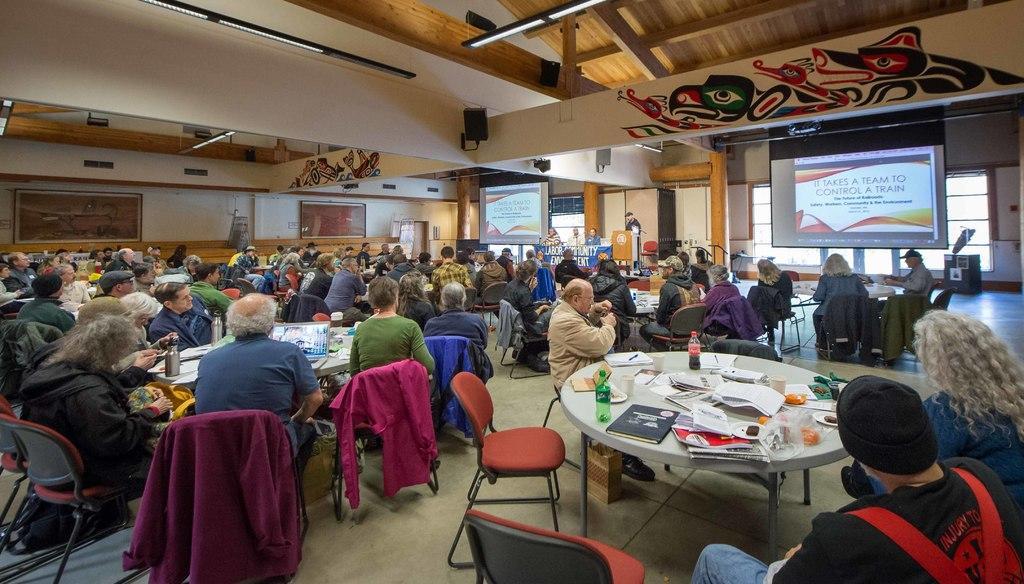In one or two sentences, can you explain what this image depicts? In this image there are group of people sitting on a chair there are two bottles, few papers, a book on a table at the back ground i can see a projector, a window,at the top there is a light. 